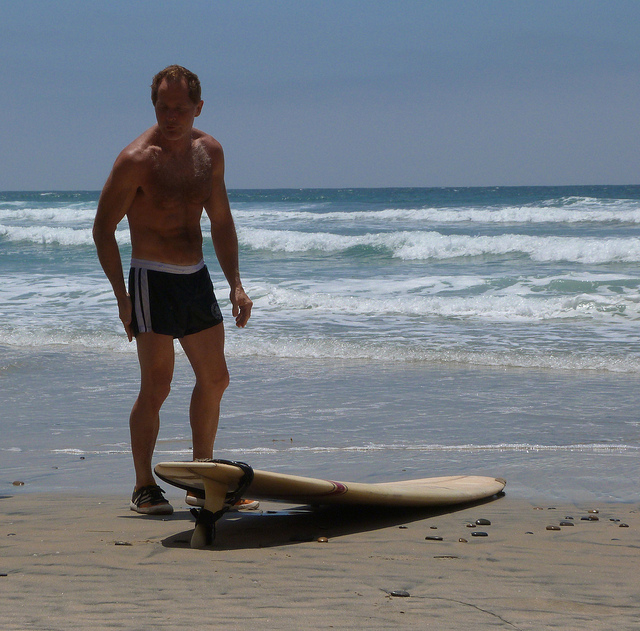Do you think the man has a regular surfing routine? Why or why not? It is plausible that the man has a regular surfing routine. His familiarity with the equipment and the confident stance suggest that he is experienced and possibly dedicated to surfing, indicating that he likely engages in the sport frequently. Describe a hypothetical surfing competition in which the man participates. The beach comes alive with the excitement of the annual surfing competition. Participants from all around gather at the shoreline, each eager to showcase their skills. Our man steps forward, his eyes locked on the horizon as he sizes up the waves. When his turn arrives, he paddles out into the ocean with practiced ease. As a massive wave approaches, he catches it perfectly, demonstrating his agility and balance with a series of seamless maneuvers. The crowd roars with approval as he rides the wave all the way to the shore, flawlessly dismounting his board. The judges, impressed by his technical prowess and style, award him with high marks, making him a strong contender for the championship. 